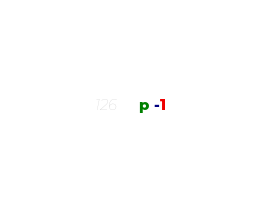<code> <loc_0><loc_0><loc_500><loc_500><_Ruby_>p -1</code> 